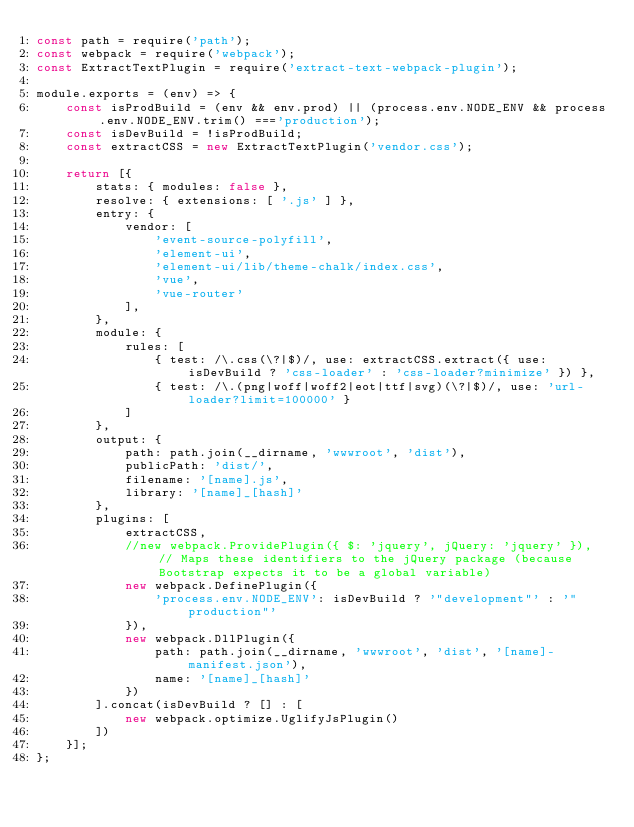Convert code to text. <code><loc_0><loc_0><loc_500><loc_500><_JavaScript_>const path = require('path');
const webpack = require('webpack');
const ExtractTextPlugin = require('extract-text-webpack-plugin');

module.exports = (env) => {
    const isProdBuild = (env && env.prod) || (process.env.NODE_ENV && process.env.NODE_ENV.trim() ==='production');
    const isDevBuild = !isProdBuild;
    const extractCSS = new ExtractTextPlugin('vendor.css');

    return [{
        stats: { modules: false },
        resolve: { extensions: [ '.js' ] },
        entry: {
            vendor: [
                'event-source-polyfill',
                'element-ui',
                'element-ui/lib/theme-chalk/index.css',
                'vue',
                'vue-router'
            ],
        },
        module: {
            rules: [
                { test: /\.css(\?|$)/, use: extractCSS.extract({ use: isDevBuild ? 'css-loader' : 'css-loader?minimize' }) },
                { test: /\.(png|woff|woff2|eot|ttf|svg)(\?|$)/, use: 'url-loader?limit=100000' }
            ]
        },
        output: { 
            path: path.join(__dirname, 'wwwroot', 'dist'),
            publicPath: 'dist/',
            filename: '[name].js',
            library: '[name]_[hash]'
        },
        plugins: [
            extractCSS,
            //new webpack.ProvidePlugin({ $: 'jquery', jQuery: 'jquery' }), // Maps these identifiers to the jQuery package (because Bootstrap expects it to be a global variable)
            new webpack.DefinePlugin({
                'process.env.NODE_ENV': isDevBuild ? '"development"' : '"production"'
            }),
            new webpack.DllPlugin({
                path: path.join(__dirname, 'wwwroot', 'dist', '[name]-manifest.json'),
                name: '[name]_[hash]'
            })
        ].concat(isDevBuild ? [] : [
            new webpack.optimize.UglifyJsPlugin()
        ])
    }];
};
</code> 